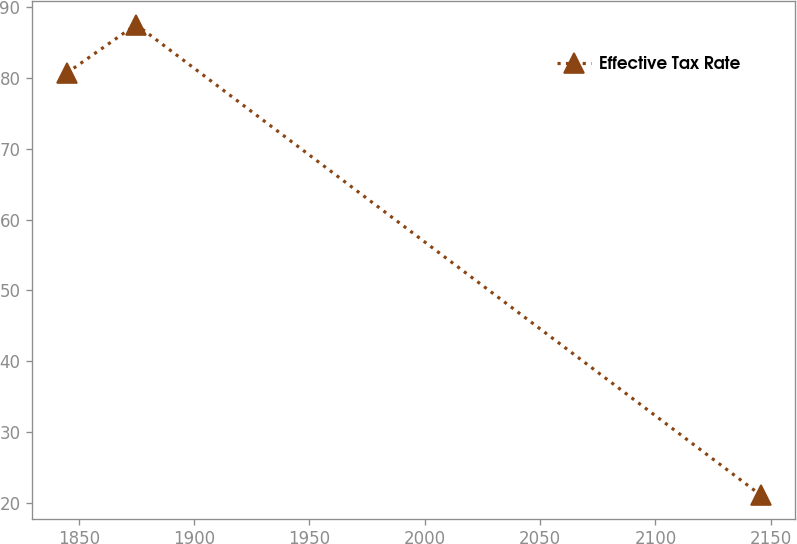<chart> <loc_0><loc_0><loc_500><loc_500><line_chart><ecel><fcel>Effective Tax Rate<nl><fcel>1844.81<fcel>80.64<nl><fcel>1874.89<fcel>87.47<nl><fcel>2145.62<fcel>21.19<nl></chart> 